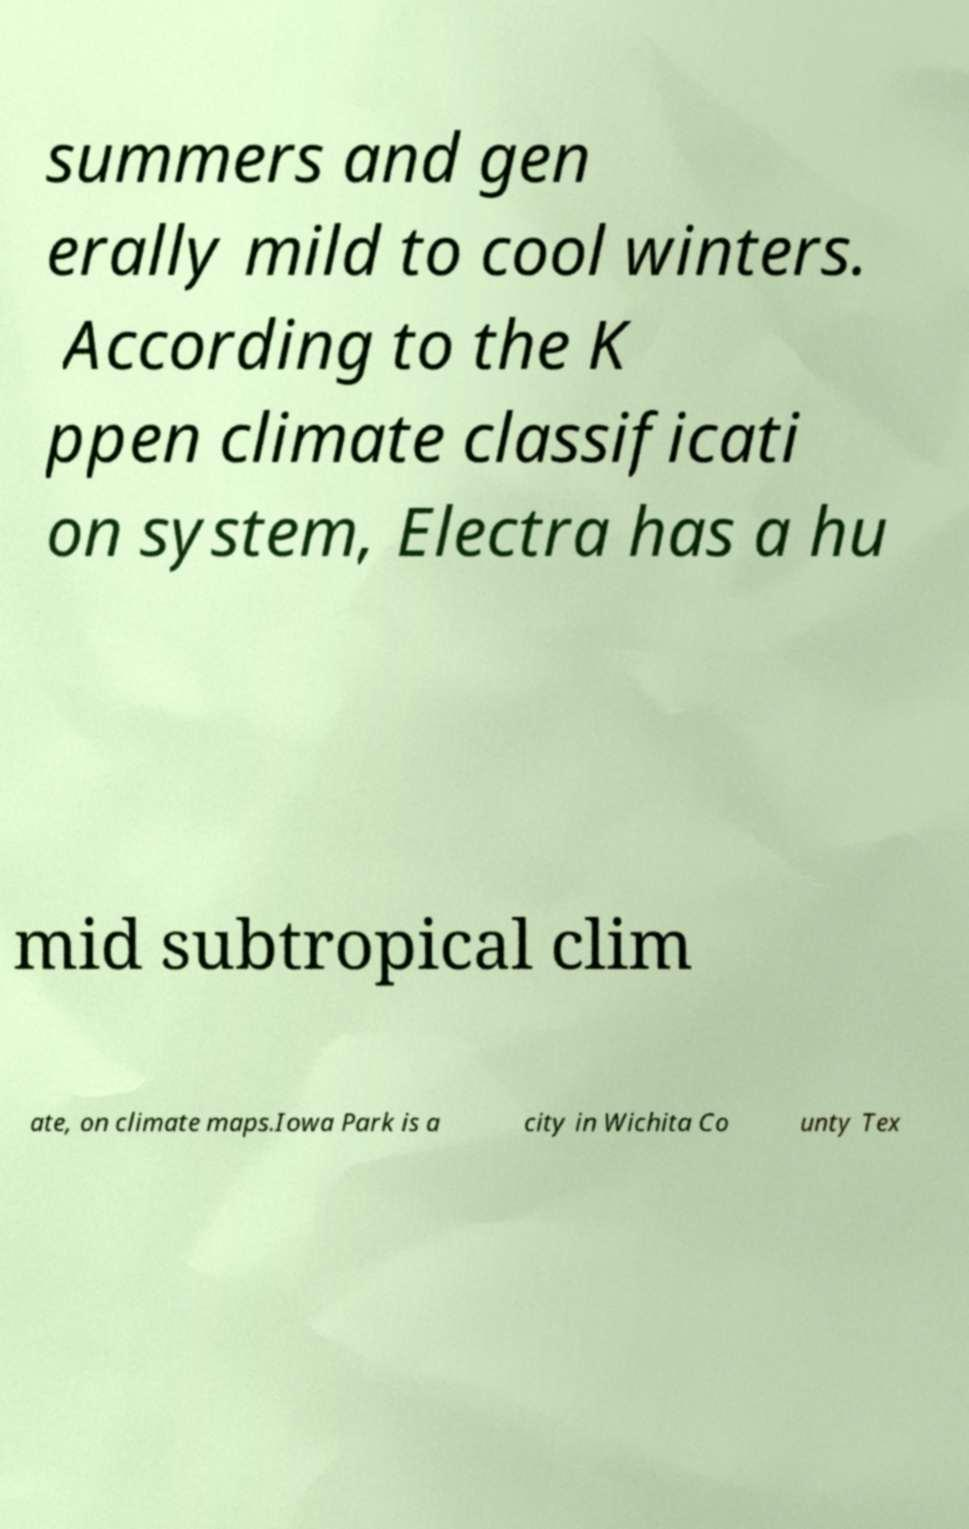Can you read and provide the text displayed in the image?This photo seems to have some interesting text. Can you extract and type it out for me? summers and gen erally mild to cool winters. According to the K ppen climate classificati on system, Electra has a hu mid subtropical clim ate, on climate maps.Iowa Park is a city in Wichita Co unty Tex 